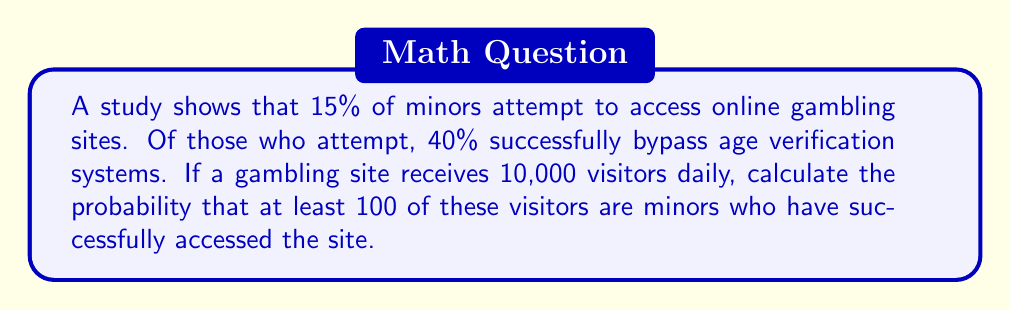Solve this math problem. Let's approach this step-by-step:

1) First, let's calculate the probability of a single visitor being a minor who successfully accesses the site:
   
   $P(\text{minor and success}) = P(\text{minor}) \times P(\text{success | minor})$
   $= 0.15 \times 0.40 = 0.06$

2) Now, we're dealing with a binomial probability problem. We want to find the probability of at least 100 successes out of 10,000 trials, where each trial has a 0.06 probability of success.

3) It's easier to calculate the probability of fewer than 100 successes and subtract from 1:

   $P(\text{at least 100}) = 1 - P(\text{fewer than 100})$

4) We can use the cumulative binomial probability function:

   $P(\text{fewer than 100}) = \sum_{k=0}^{99} \binom{10000}{k} (0.06)^k (0.94)^{10000-k}$

5) This sum is difficult to calculate by hand, so we would typically use statistical software or a calculator with a cumulative binomial probability function.

6) Using such a tool, we find:

   $P(\text{fewer than 100}) \approx 0.0000000002$

7) Therefore:

   $P(\text{at least 100}) = 1 - 0.0000000002 \approx 0.9999999998$
Answer: $0.9999999998$ 